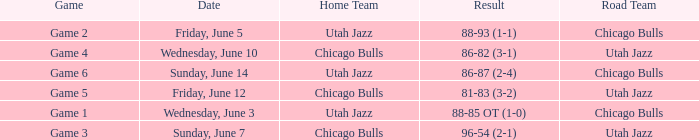Help me parse the entirety of this table. {'header': ['Game', 'Date', 'Home Team', 'Result', 'Road Team'], 'rows': [['Game 2', 'Friday, June 5', 'Utah Jazz', '88-93 (1-1)', 'Chicago Bulls'], ['Game 4', 'Wednesday, June 10', 'Chicago Bulls', '86-82 (3-1)', 'Utah Jazz'], ['Game 6', 'Sunday, June 14', 'Utah Jazz', '86-87 (2-4)', 'Chicago Bulls'], ['Game 5', 'Friday, June 12', 'Chicago Bulls', '81-83 (3-2)', 'Utah Jazz'], ['Game 1', 'Wednesday, June 3', 'Utah Jazz', '88-85 OT (1-0)', 'Chicago Bulls'], ['Game 3', 'Sunday, June 7', 'Chicago Bulls', '96-54 (2-1)', 'Utah Jazz']]} What game has a score of 86-87 (2-4)? Game 6. 